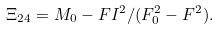<formula> <loc_0><loc_0><loc_500><loc_500>\Xi _ { 2 4 } = M _ { 0 } - F I ^ { 2 } / ( F _ { 0 } ^ { 2 } - F ^ { 2 } ) .</formula> 